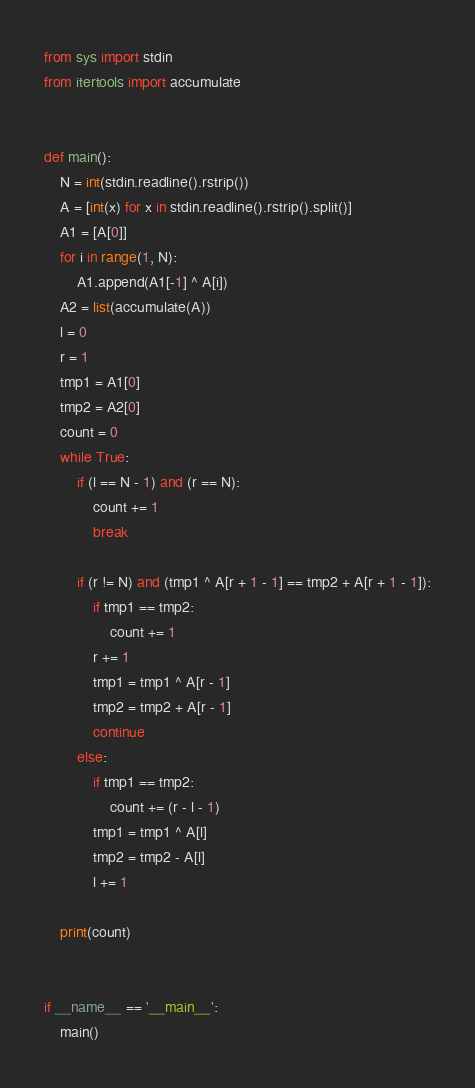Convert code to text. <code><loc_0><loc_0><loc_500><loc_500><_Python_>from sys import stdin
from itertools import accumulate


def main():
    N = int(stdin.readline().rstrip())
    A = [int(x) for x in stdin.readline().rstrip().split()]
    A1 = [A[0]]
    for i in range(1, N):
        A1.append(A1[-1] ^ A[i])
    A2 = list(accumulate(A))
    l = 0
    r = 1
    tmp1 = A1[0]
    tmp2 = A2[0]
    count = 0
    while True:
        if (l == N - 1) and (r == N):
            count += 1
            break

        if (r != N) and (tmp1 ^ A[r + 1 - 1] == tmp2 + A[r + 1 - 1]):
            if tmp1 == tmp2:
                count += 1
            r += 1
            tmp1 = tmp1 ^ A[r - 1]
            tmp2 = tmp2 + A[r - 1]
            continue
        else:
            if tmp1 == tmp2:
                count += (r - l - 1)
            tmp1 = tmp1 ^ A[l]
            tmp2 = tmp2 - A[l]
            l += 1

    print(count)


if __name__ == '__main__':
    main()
</code> 